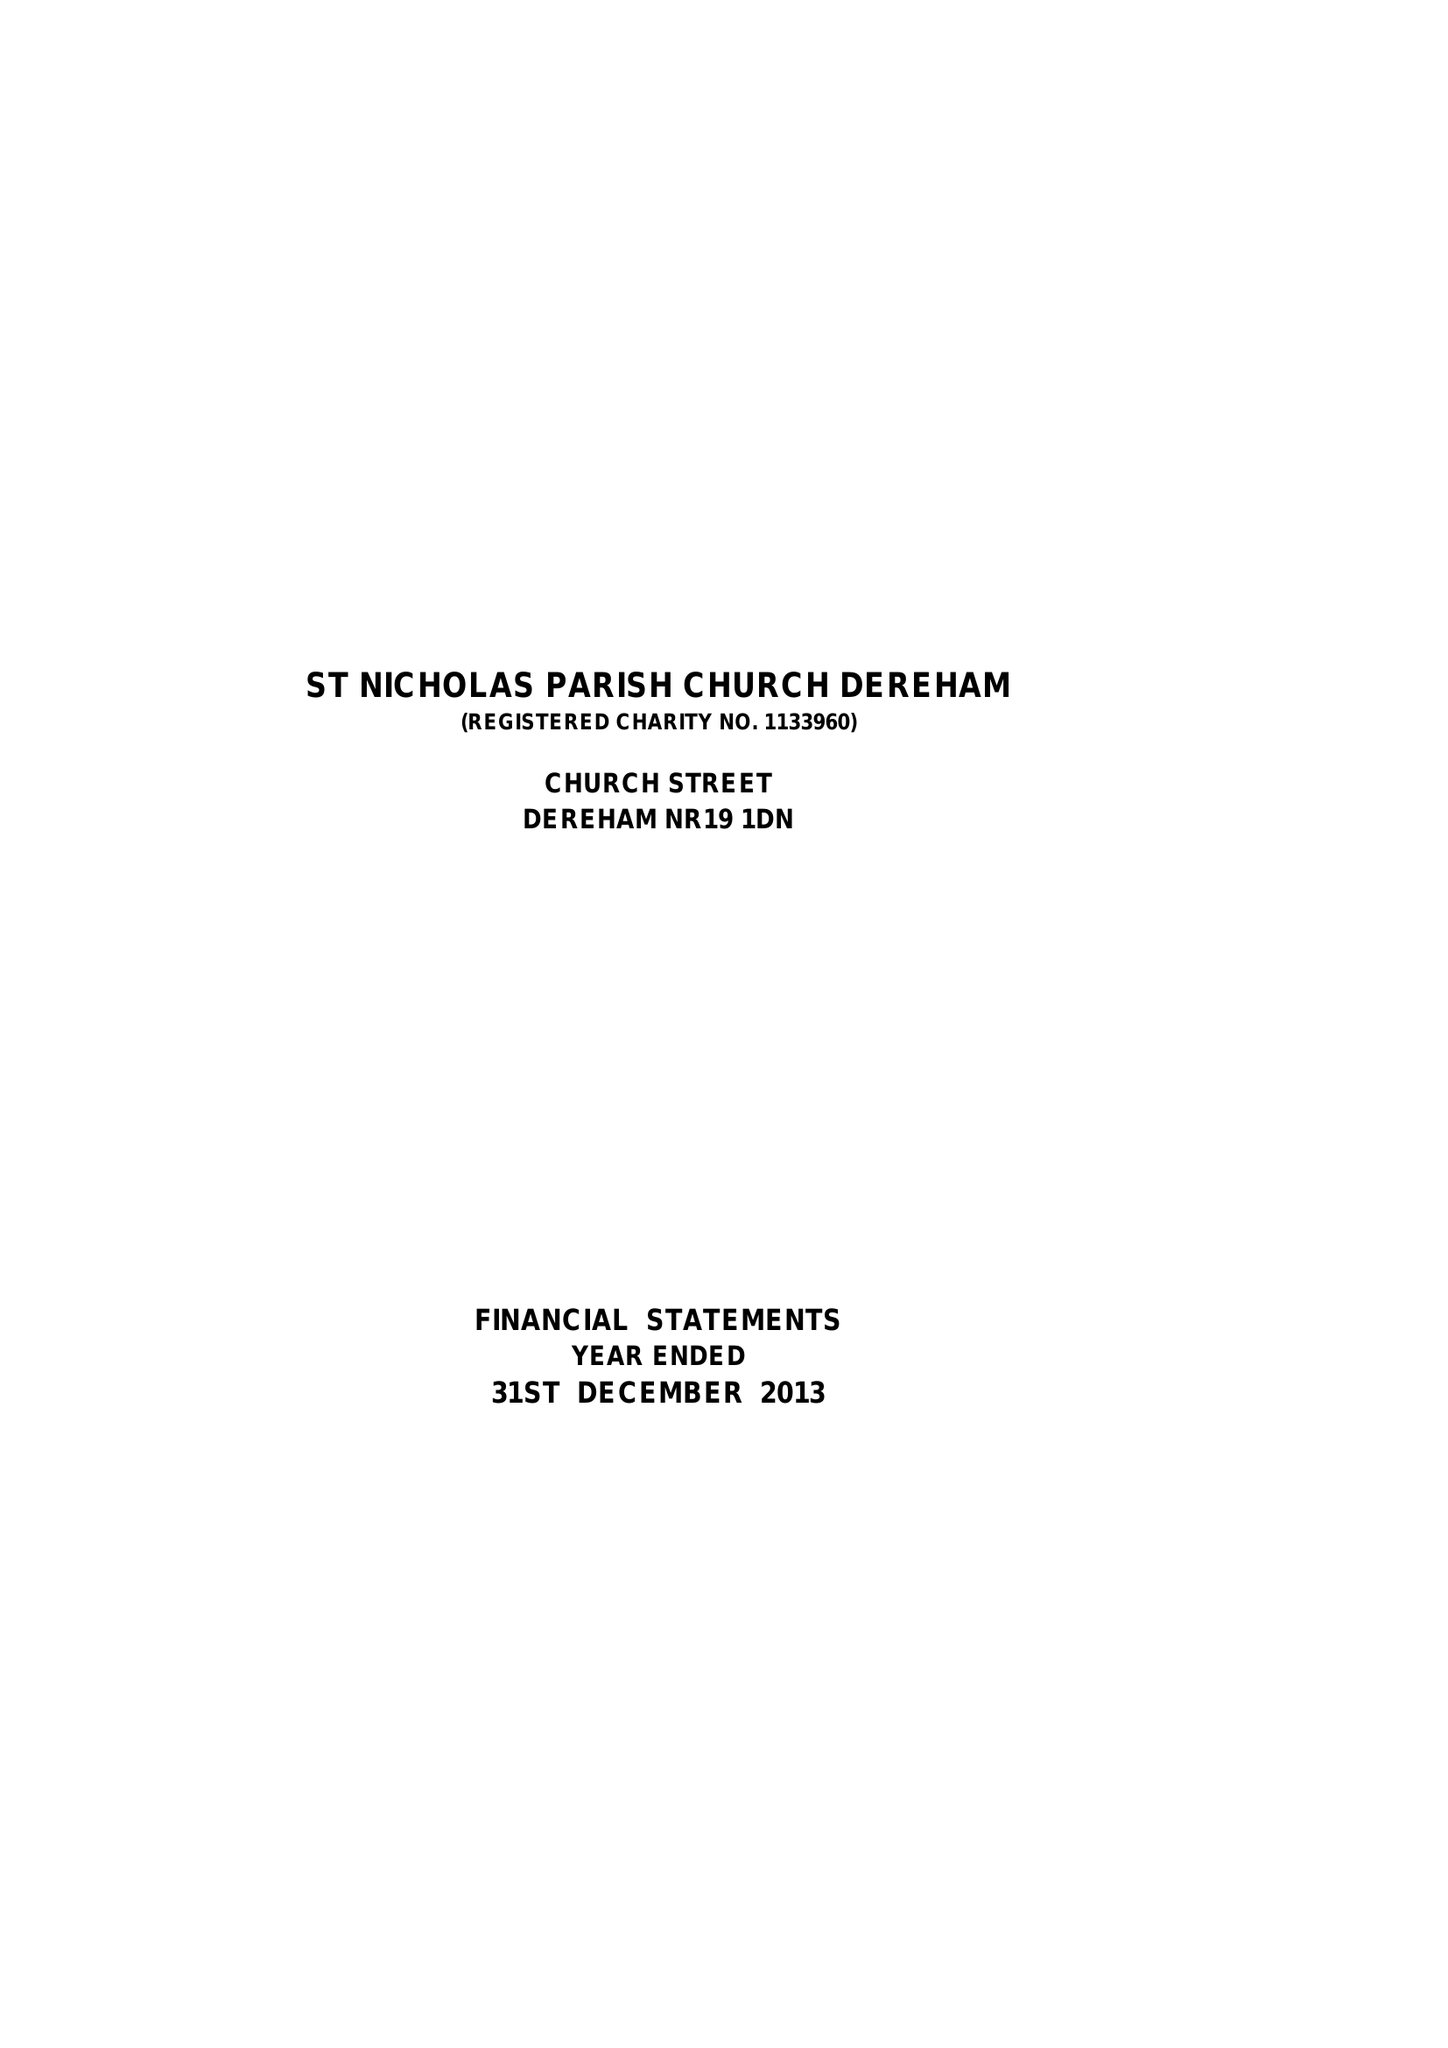What is the value for the address__street_line?
Answer the question using a single word or phrase. CHURCH STREET 